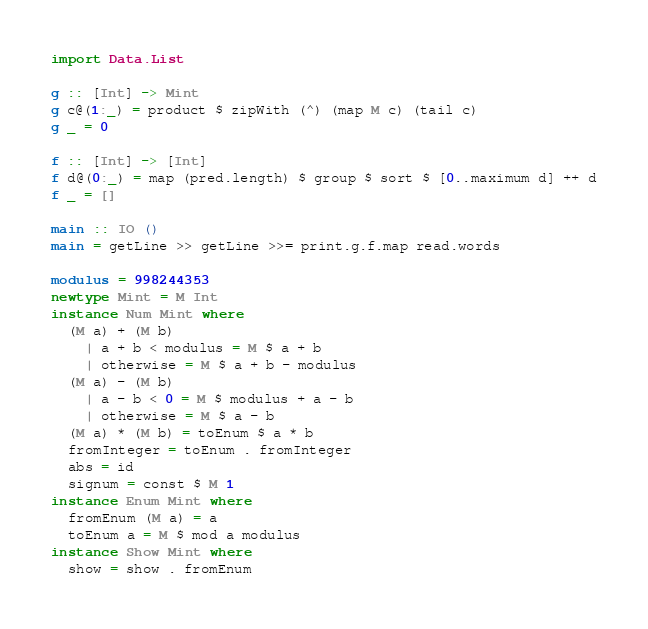<code> <loc_0><loc_0><loc_500><loc_500><_Haskell_>import Data.List

g :: [Int] -> Mint
g c@(1:_) = product $ zipWith (^) (map M c) (tail c)
g _ = 0

f :: [Int] -> [Int]
f d@(0:_) = map (pred.length) $ group $ sort $ [0..maximum d] ++ d
f _ = []

main :: IO ()
main = getLine >> getLine >>= print.g.f.map read.words

modulus = 998244353
newtype Mint = M Int
instance Num Mint where
  (M a) + (M b)
    | a + b < modulus = M $ a + b
    | otherwise = M $ a + b - modulus
  (M a) - (M b)
    | a - b < 0 = M $ modulus + a - b
    | otherwise = M $ a - b
  (M a) * (M b) = toEnum $ a * b
  fromInteger = toEnum . fromInteger
  abs = id
  signum = const $ M 1
instance Enum Mint where
  fromEnum (M a) = a
  toEnum a = M $ mod a modulus
instance Show Mint where
  show = show . fromEnum</code> 